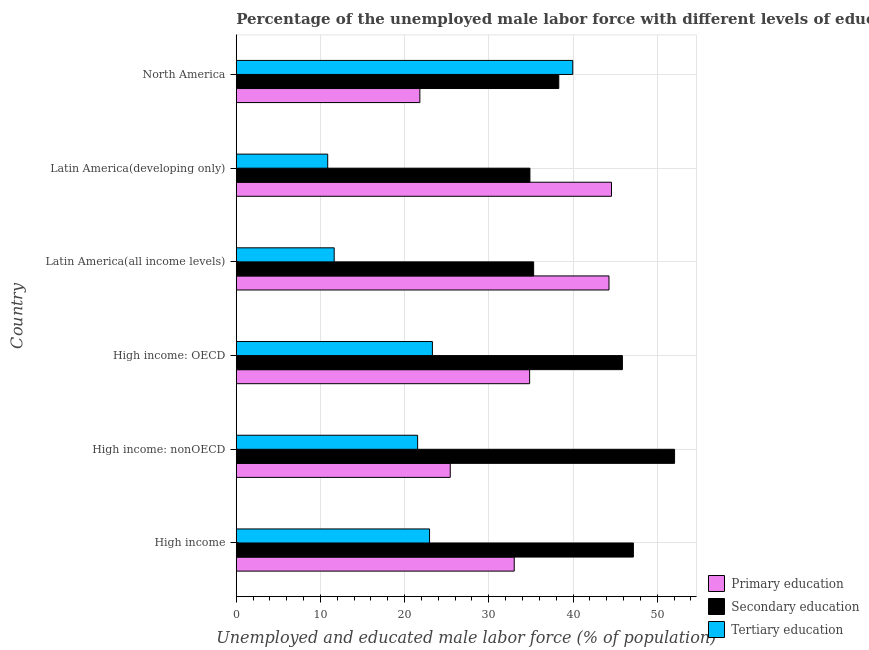Are the number of bars per tick equal to the number of legend labels?
Ensure brevity in your answer.  Yes. Are the number of bars on each tick of the Y-axis equal?
Provide a short and direct response. Yes. What is the label of the 3rd group of bars from the top?
Ensure brevity in your answer.  Latin America(all income levels). What is the percentage of male labor force who received tertiary education in High income: nonOECD?
Make the answer very short. 21.54. Across all countries, what is the maximum percentage of male labor force who received tertiary education?
Give a very brief answer. 39.97. Across all countries, what is the minimum percentage of male labor force who received tertiary education?
Your answer should be very brief. 10.86. In which country was the percentage of male labor force who received secondary education maximum?
Your response must be concise. High income: nonOECD. In which country was the percentage of male labor force who received primary education minimum?
Your response must be concise. North America. What is the total percentage of male labor force who received primary education in the graph?
Provide a short and direct response. 203.93. What is the difference between the percentage of male labor force who received primary education in High income and that in High income: nonOECD?
Your response must be concise. 7.6. What is the difference between the percentage of male labor force who received primary education in High income: OECD and the percentage of male labor force who received tertiary education in Latin America(all income levels)?
Give a very brief answer. 23.21. What is the average percentage of male labor force who received tertiary education per country?
Your response must be concise. 21.71. What is the difference between the percentage of male labor force who received tertiary education and percentage of male labor force who received secondary education in North America?
Make the answer very short. 1.66. What is the ratio of the percentage of male labor force who received secondary education in High income: nonOECD to that in Latin America(all income levels)?
Ensure brevity in your answer.  1.47. Is the percentage of male labor force who received primary education in High income: OECD less than that in North America?
Offer a very short reply. No. What is the difference between the highest and the second highest percentage of male labor force who received secondary education?
Your answer should be compact. 4.89. What is the difference between the highest and the lowest percentage of male labor force who received tertiary education?
Provide a succinct answer. 29.11. In how many countries, is the percentage of male labor force who received primary education greater than the average percentage of male labor force who received primary education taken over all countries?
Provide a short and direct response. 3. Is the sum of the percentage of male labor force who received primary education in High income: nonOECD and Latin America(all income levels) greater than the maximum percentage of male labor force who received tertiary education across all countries?
Ensure brevity in your answer.  Yes. What does the 2nd bar from the top in North America represents?
Your response must be concise. Secondary education. Does the graph contain any zero values?
Your answer should be compact. No. How many legend labels are there?
Provide a succinct answer. 3. How are the legend labels stacked?
Give a very brief answer. Vertical. What is the title of the graph?
Provide a short and direct response. Percentage of the unemployed male labor force with different levels of education in countries. Does "Domestic economy" appear as one of the legend labels in the graph?
Offer a terse response. No. What is the label or title of the X-axis?
Provide a succinct answer. Unemployed and educated male labor force (% of population). What is the label or title of the Y-axis?
Ensure brevity in your answer.  Country. What is the Unemployed and educated male labor force (% of population) of Primary education in High income?
Your answer should be compact. 33.02. What is the Unemployed and educated male labor force (% of population) of Secondary education in High income?
Make the answer very short. 47.17. What is the Unemployed and educated male labor force (% of population) in Tertiary education in High income?
Ensure brevity in your answer.  22.96. What is the Unemployed and educated male labor force (% of population) of Primary education in High income: nonOECD?
Keep it short and to the point. 25.42. What is the Unemployed and educated male labor force (% of population) in Secondary education in High income: nonOECD?
Ensure brevity in your answer.  52.06. What is the Unemployed and educated male labor force (% of population) in Tertiary education in High income: nonOECD?
Offer a terse response. 21.54. What is the Unemployed and educated male labor force (% of population) of Primary education in High income: OECD?
Offer a very short reply. 34.84. What is the Unemployed and educated male labor force (% of population) in Secondary education in High income: OECD?
Your answer should be compact. 45.86. What is the Unemployed and educated male labor force (% of population) in Tertiary education in High income: OECD?
Give a very brief answer. 23.3. What is the Unemployed and educated male labor force (% of population) of Primary education in Latin America(all income levels)?
Your answer should be very brief. 44.27. What is the Unemployed and educated male labor force (% of population) of Secondary education in Latin America(all income levels)?
Ensure brevity in your answer.  35.32. What is the Unemployed and educated male labor force (% of population) of Tertiary education in Latin America(all income levels)?
Your answer should be very brief. 11.63. What is the Unemployed and educated male labor force (% of population) in Primary education in Latin America(developing only)?
Your answer should be compact. 44.57. What is the Unemployed and educated male labor force (% of population) of Secondary education in Latin America(developing only)?
Offer a very short reply. 34.88. What is the Unemployed and educated male labor force (% of population) in Tertiary education in Latin America(developing only)?
Make the answer very short. 10.86. What is the Unemployed and educated male labor force (% of population) of Primary education in North America?
Your response must be concise. 21.81. What is the Unemployed and educated male labor force (% of population) in Secondary education in North America?
Make the answer very short. 38.31. What is the Unemployed and educated male labor force (% of population) in Tertiary education in North America?
Keep it short and to the point. 39.97. Across all countries, what is the maximum Unemployed and educated male labor force (% of population) of Primary education?
Provide a succinct answer. 44.57. Across all countries, what is the maximum Unemployed and educated male labor force (% of population) of Secondary education?
Offer a terse response. 52.06. Across all countries, what is the maximum Unemployed and educated male labor force (% of population) in Tertiary education?
Your answer should be very brief. 39.97. Across all countries, what is the minimum Unemployed and educated male labor force (% of population) in Primary education?
Your response must be concise. 21.81. Across all countries, what is the minimum Unemployed and educated male labor force (% of population) in Secondary education?
Keep it short and to the point. 34.88. Across all countries, what is the minimum Unemployed and educated male labor force (% of population) in Tertiary education?
Provide a short and direct response. 10.86. What is the total Unemployed and educated male labor force (% of population) in Primary education in the graph?
Your answer should be very brief. 203.93. What is the total Unemployed and educated male labor force (% of population) in Secondary education in the graph?
Your response must be concise. 253.61. What is the total Unemployed and educated male labor force (% of population) in Tertiary education in the graph?
Give a very brief answer. 130.27. What is the difference between the Unemployed and educated male labor force (% of population) of Primary education in High income and that in High income: nonOECD?
Keep it short and to the point. 7.6. What is the difference between the Unemployed and educated male labor force (% of population) in Secondary education in High income and that in High income: nonOECD?
Offer a very short reply. -4.89. What is the difference between the Unemployed and educated male labor force (% of population) in Tertiary education in High income and that in High income: nonOECD?
Offer a terse response. 1.42. What is the difference between the Unemployed and educated male labor force (% of population) of Primary education in High income and that in High income: OECD?
Your response must be concise. -1.83. What is the difference between the Unemployed and educated male labor force (% of population) of Secondary education in High income and that in High income: OECD?
Provide a succinct answer. 1.31. What is the difference between the Unemployed and educated male labor force (% of population) in Tertiary education in High income and that in High income: OECD?
Offer a terse response. -0.34. What is the difference between the Unemployed and educated male labor force (% of population) of Primary education in High income and that in Latin America(all income levels)?
Offer a very short reply. -11.26. What is the difference between the Unemployed and educated male labor force (% of population) of Secondary education in High income and that in Latin America(all income levels)?
Your answer should be compact. 11.85. What is the difference between the Unemployed and educated male labor force (% of population) in Tertiary education in High income and that in Latin America(all income levels)?
Make the answer very short. 11.33. What is the difference between the Unemployed and educated male labor force (% of population) in Primary education in High income and that in Latin America(developing only)?
Provide a short and direct response. -11.55. What is the difference between the Unemployed and educated male labor force (% of population) in Secondary education in High income and that in Latin America(developing only)?
Your answer should be very brief. 12.29. What is the difference between the Unemployed and educated male labor force (% of population) of Tertiary education in High income and that in Latin America(developing only)?
Give a very brief answer. 12.1. What is the difference between the Unemployed and educated male labor force (% of population) of Primary education in High income and that in North America?
Provide a succinct answer. 11.21. What is the difference between the Unemployed and educated male labor force (% of population) in Secondary education in High income and that in North America?
Offer a terse response. 8.86. What is the difference between the Unemployed and educated male labor force (% of population) in Tertiary education in High income and that in North America?
Provide a short and direct response. -17.01. What is the difference between the Unemployed and educated male labor force (% of population) in Primary education in High income: nonOECD and that in High income: OECD?
Your response must be concise. -9.43. What is the difference between the Unemployed and educated male labor force (% of population) of Secondary education in High income: nonOECD and that in High income: OECD?
Make the answer very short. 6.2. What is the difference between the Unemployed and educated male labor force (% of population) in Tertiary education in High income: nonOECD and that in High income: OECD?
Ensure brevity in your answer.  -1.76. What is the difference between the Unemployed and educated male labor force (% of population) in Primary education in High income: nonOECD and that in Latin America(all income levels)?
Offer a terse response. -18.85. What is the difference between the Unemployed and educated male labor force (% of population) of Secondary education in High income: nonOECD and that in Latin America(all income levels)?
Your answer should be compact. 16.74. What is the difference between the Unemployed and educated male labor force (% of population) of Tertiary education in High income: nonOECD and that in Latin America(all income levels)?
Offer a terse response. 9.91. What is the difference between the Unemployed and educated male labor force (% of population) in Primary education in High income: nonOECD and that in Latin America(developing only)?
Your response must be concise. -19.15. What is the difference between the Unemployed and educated male labor force (% of population) of Secondary education in High income: nonOECD and that in Latin America(developing only)?
Provide a succinct answer. 17.18. What is the difference between the Unemployed and educated male labor force (% of population) of Tertiary education in High income: nonOECD and that in Latin America(developing only)?
Give a very brief answer. 10.68. What is the difference between the Unemployed and educated male labor force (% of population) in Primary education in High income: nonOECD and that in North America?
Your response must be concise. 3.61. What is the difference between the Unemployed and educated male labor force (% of population) in Secondary education in High income: nonOECD and that in North America?
Your response must be concise. 13.75. What is the difference between the Unemployed and educated male labor force (% of population) of Tertiary education in High income: nonOECD and that in North America?
Your answer should be very brief. -18.43. What is the difference between the Unemployed and educated male labor force (% of population) of Primary education in High income: OECD and that in Latin America(all income levels)?
Keep it short and to the point. -9.43. What is the difference between the Unemployed and educated male labor force (% of population) in Secondary education in High income: OECD and that in Latin America(all income levels)?
Keep it short and to the point. 10.54. What is the difference between the Unemployed and educated male labor force (% of population) in Tertiary education in High income: OECD and that in Latin America(all income levels)?
Offer a terse response. 11.67. What is the difference between the Unemployed and educated male labor force (% of population) of Primary education in High income: OECD and that in Latin America(developing only)?
Offer a very short reply. -9.72. What is the difference between the Unemployed and educated male labor force (% of population) in Secondary education in High income: OECD and that in Latin America(developing only)?
Ensure brevity in your answer.  10.98. What is the difference between the Unemployed and educated male labor force (% of population) of Tertiary education in High income: OECD and that in Latin America(developing only)?
Provide a succinct answer. 12.44. What is the difference between the Unemployed and educated male labor force (% of population) of Primary education in High income: OECD and that in North America?
Provide a succinct answer. 13.04. What is the difference between the Unemployed and educated male labor force (% of population) in Secondary education in High income: OECD and that in North America?
Keep it short and to the point. 7.55. What is the difference between the Unemployed and educated male labor force (% of population) in Tertiary education in High income: OECD and that in North America?
Make the answer very short. -16.67. What is the difference between the Unemployed and educated male labor force (% of population) in Primary education in Latin America(all income levels) and that in Latin America(developing only)?
Your response must be concise. -0.3. What is the difference between the Unemployed and educated male labor force (% of population) of Secondary education in Latin America(all income levels) and that in Latin America(developing only)?
Your response must be concise. 0.44. What is the difference between the Unemployed and educated male labor force (% of population) in Tertiary education in Latin America(all income levels) and that in Latin America(developing only)?
Make the answer very short. 0.77. What is the difference between the Unemployed and educated male labor force (% of population) of Primary education in Latin America(all income levels) and that in North America?
Offer a terse response. 22.46. What is the difference between the Unemployed and educated male labor force (% of population) of Secondary education in Latin America(all income levels) and that in North America?
Your response must be concise. -2.99. What is the difference between the Unemployed and educated male labor force (% of population) in Tertiary education in Latin America(all income levels) and that in North America?
Give a very brief answer. -28.34. What is the difference between the Unemployed and educated male labor force (% of population) in Primary education in Latin America(developing only) and that in North America?
Ensure brevity in your answer.  22.76. What is the difference between the Unemployed and educated male labor force (% of population) in Secondary education in Latin America(developing only) and that in North America?
Your answer should be compact. -3.43. What is the difference between the Unemployed and educated male labor force (% of population) in Tertiary education in Latin America(developing only) and that in North America?
Provide a short and direct response. -29.11. What is the difference between the Unemployed and educated male labor force (% of population) of Primary education in High income and the Unemployed and educated male labor force (% of population) of Secondary education in High income: nonOECD?
Your answer should be compact. -19.04. What is the difference between the Unemployed and educated male labor force (% of population) of Primary education in High income and the Unemployed and educated male labor force (% of population) of Tertiary education in High income: nonOECD?
Your answer should be compact. 11.47. What is the difference between the Unemployed and educated male labor force (% of population) in Secondary education in High income and the Unemployed and educated male labor force (% of population) in Tertiary education in High income: nonOECD?
Ensure brevity in your answer.  25.63. What is the difference between the Unemployed and educated male labor force (% of population) in Primary education in High income and the Unemployed and educated male labor force (% of population) in Secondary education in High income: OECD?
Provide a succinct answer. -12.85. What is the difference between the Unemployed and educated male labor force (% of population) in Primary education in High income and the Unemployed and educated male labor force (% of population) in Tertiary education in High income: OECD?
Ensure brevity in your answer.  9.72. What is the difference between the Unemployed and educated male labor force (% of population) in Secondary education in High income and the Unemployed and educated male labor force (% of population) in Tertiary education in High income: OECD?
Keep it short and to the point. 23.87. What is the difference between the Unemployed and educated male labor force (% of population) in Primary education in High income and the Unemployed and educated male labor force (% of population) in Secondary education in Latin America(all income levels)?
Provide a succinct answer. -2.31. What is the difference between the Unemployed and educated male labor force (% of population) of Primary education in High income and the Unemployed and educated male labor force (% of population) of Tertiary education in Latin America(all income levels)?
Keep it short and to the point. 21.38. What is the difference between the Unemployed and educated male labor force (% of population) of Secondary education in High income and the Unemployed and educated male labor force (% of population) of Tertiary education in Latin America(all income levels)?
Make the answer very short. 35.54. What is the difference between the Unemployed and educated male labor force (% of population) in Primary education in High income and the Unemployed and educated male labor force (% of population) in Secondary education in Latin America(developing only)?
Offer a terse response. -1.86. What is the difference between the Unemployed and educated male labor force (% of population) of Primary education in High income and the Unemployed and educated male labor force (% of population) of Tertiary education in Latin America(developing only)?
Your response must be concise. 22.15. What is the difference between the Unemployed and educated male labor force (% of population) of Secondary education in High income and the Unemployed and educated male labor force (% of population) of Tertiary education in Latin America(developing only)?
Your response must be concise. 36.31. What is the difference between the Unemployed and educated male labor force (% of population) in Primary education in High income and the Unemployed and educated male labor force (% of population) in Secondary education in North America?
Keep it short and to the point. -5.29. What is the difference between the Unemployed and educated male labor force (% of population) of Primary education in High income and the Unemployed and educated male labor force (% of population) of Tertiary education in North America?
Offer a terse response. -6.95. What is the difference between the Unemployed and educated male labor force (% of population) of Secondary education in High income and the Unemployed and educated male labor force (% of population) of Tertiary education in North America?
Your answer should be compact. 7.2. What is the difference between the Unemployed and educated male labor force (% of population) of Primary education in High income: nonOECD and the Unemployed and educated male labor force (% of population) of Secondary education in High income: OECD?
Make the answer very short. -20.45. What is the difference between the Unemployed and educated male labor force (% of population) of Primary education in High income: nonOECD and the Unemployed and educated male labor force (% of population) of Tertiary education in High income: OECD?
Keep it short and to the point. 2.12. What is the difference between the Unemployed and educated male labor force (% of population) in Secondary education in High income: nonOECD and the Unemployed and educated male labor force (% of population) in Tertiary education in High income: OECD?
Provide a short and direct response. 28.76. What is the difference between the Unemployed and educated male labor force (% of population) in Primary education in High income: nonOECD and the Unemployed and educated male labor force (% of population) in Secondary education in Latin America(all income levels)?
Give a very brief answer. -9.9. What is the difference between the Unemployed and educated male labor force (% of population) in Primary education in High income: nonOECD and the Unemployed and educated male labor force (% of population) in Tertiary education in Latin America(all income levels)?
Give a very brief answer. 13.79. What is the difference between the Unemployed and educated male labor force (% of population) of Secondary education in High income: nonOECD and the Unemployed and educated male labor force (% of population) of Tertiary education in Latin America(all income levels)?
Offer a terse response. 40.43. What is the difference between the Unemployed and educated male labor force (% of population) in Primary education in High income: nonOECD and the Unemployed and educated male labor force (% of population) in Secondary education in Latin America(developing only)?
Your answer should be very brief. -9.46. What is the difference between the Unemployed and educated male labor force (% of population) in Primary education in High income: nonOECD and the Unemployed and educated male labor force (% of population) in Tertiary education in Latin America(developing only)?
Provide a succinct answer. 14.56. What is the difference between the Unemployed and educated male labor force (% of population) in Secondary education in High income: nonOECD and the Unemployed and educated male labor force (% of population) in Tertiary education in Latin America(developing only)?
Give a very brief answer. 41.2. What is the difference between the Unemployed and educated male labor force (% of population) of Primary education in High income: nonOECD and the Unemployed and educated male labor force (% of population) of Secondary education in North America?
Offer a very short reply. -12.89. What is the difference between the Unemployed and educated male labor force (% of population) in Primary education in High income: nonOECD and the Unemployed and educated male labor force (% of population) in Tertiary education in North America?
Your answer should be compact. -14.55. What is the difference between the Unemployed and educated male labor force (% of population) of Secondary education in High income: nonOECD and the Unemployed and educated male labor force (% of population) of Tertiary education in North America?
Give a very brief answer. 12.09. What is the difference between the Unemployed and educated male labor force (% of population) in Primary education in High income: OECD and the Unemployed and educated male labor force (% of population) in Secondary education in Latin America(all income levels)?
Provide a succinct answer. -0.48. What is the difference between the Unemployed and educated male labor force (% of population) of Primary education in High income: OECD and the Unemployed and educated male labor force (% of population) of Tertiary education in Latin America(all income levels)?
Offer a terse response. 23.21. What is the difference between the Unemployed and educated male labor force (% of population) in Secondary education in High income: OECD and the Unemployed and educated male labor force (% of population) in Tertiary education in Latin America(all income levels)?
Your response must be concise. 34.23. What is the difference between the Unemployed and educated male labor force (% of population) of Primary education in High income: OECD and the Unemployed and educated male labor force (% of population) of Secondary education in Latin America(developing only)?
Ensure brevity in your answer.  -0.04. What is the difference between the Unemployed and educated male labor force (% of population) in Primary education in High income: OECD and the Unemployed and educated male labor force (% of population) in Tertiary education in Latin America(developing only)?
Make the answer very short. 23.98. What is the difference between the Unemployed and educated male labor force (% of population) of Secondary education in High income: OECD and the Unemployed and educated male labor force (% of population) of Tertiary education in Latin America(developing only)?
Provide a short and direct response. 35. What is the difference between the Unemployed and educated male labor force (% of population) in Primary education in High income: OECD and the Unemployed and educated male labor force (% of population) in Secondary education in North America?
Ensure brevity in your answer.  -3.46. What is the difference between the Unemployed and educated male labor force (% of population) of Primary education in High income: OECD and the Unemployed and educated male labor force (% of population) of Tertiary education in North America?
Offer a very short reply. -5.12. What is the difference between the Unemployed and educated male labor force (% of population) in Secondary education in High income: OECD and the Unemployed and educated male labor force (% of population) in Tertiary education in North America?
Provide a short and direct response. 5.89. What is the difference between the Unemployed and educated male labor force (% of population) of Primary education in Latin America(all income levels) and the Unemployed and educated male labor force (% of population) of Secondary education in Latin America(developing only)?
Offer a very short reply. 9.39. What is the difference between the Unemployed and educated male labor force (% of population) of Primary education in Latin America(all income levels) and the Unemployed and educated male labor force (% of population) of Tertiary education in Latin America(developing only)?
Provide a short and direct response. 33.41. What is the difference between the Unemployed and educated male labor force (% of population) in Secondary education in Latin America(all income levels) and the Unemployed and educated male labor force (% of population) in Tertiary education in Latin America(developing only)?
Provide a short and direct response. 24.46. What is the difference between the Unemployed and educated male labor force (% of population) in Primary education in Latin America(all income levels) and the Unemployed and educated male labor force (% of population) in Secondary education in North America?
Provide a succinct answer. 5.96. What is the difference between the Unemployed and educated male labor force (% of population) in Primary education in Latin America(all income levels) and the Unemployed and educated male labor force (% of population) in Tertiary education in North America?
Your response must be concise. 4.3. What is the difference between the Unemployed and educated male labor force (% of population) of Secondary education in Latin America(all income levels) and the Unemployed and educated male labor force (% of population) of Tertiary education in North America?
Your response must be concise. -4.65. What is the difference between the Unemployed and educated male labor force (% of population) in Primary education in Latin America(developing only) and the Unemployed and educated male labor force (% of population) in Secondary education in North America?
Give a very brief answer. 6.26. What is the difference between the Unemployed and educated male labor force (% of population) of Primary education in Latin America(developing only) and the Unemployed and educated male labor force (% of population) of Tertiary education in North America?
Offer a very short reply. 4.6. What is the difference between the Unemployed and educated male labor force (% of population) of Secondary education in Latin America(developing only) and the Unemployed and educated male labor force (% of population) of Tertiary education in North America?
Provide a succinct answer. -5.09. What is the average Unemployed and educated male labor force (% of population) in Primary education per country?
Offer a very short reply. 33.99. What is the average Unemployed and educated male labor force (% of population) of Secondary education per country?
Ensure brevity in your answer.  42.27. What is the average Unemployed and educated male labor force (% of population) in Tertiary education per country?
Ensure brevity in your answer.  21.71. What is the difference between the Unemployed and educated male labor force (% of population) of Primary education and Unemployed and educated male labor force (% of population) of Secondary education in High income?
Provide a short and direct response. -14.15. What is the difference between the Unemployed and educated male labor force (% of population) of Primary education and Unemployed and educated male labor force (% of population) of Tertiary education in High income?
Your answer should be compact. 10.06. What is the difference between the Unemployed and educated male labor force (% of population) of Secondary education and Unemployed and educated male labor force (% of population) of Tertiary education in High income?
Give a very brief answer. 24.21. What is the difference between the Unemployed and educated male labor force (% of population) in Primary education and Unemployed and educated male labor force (% of population) in Secondary education in High income: nonOECD?
Ensure brevity in your answer.  -26.64. What is the difference between the Unemployed and educated male labor force (% of population) in Primary education and Unemployed and educated male labor force (% of population) in Tertiary education in High income: nonOECD?
Make the answer very short. 3.87. What is the difference between the Unemployed and educated male labor force (% of population) of Secondary education and Unemployed and educated male labor force (% of population) of Tertiary education in High income: nonOECD?
Keep it short and to the point. 30.52. What is the difference between the Unemployed and educated male labor force (% of population) of Primary education and Unemployed and educated male labor force (% of population) of Secondary education in High income: OECD?
Offer a terse response. -11.02. What is the difference between the Unemployed and educated male labor force (% of population) of Primary education and Unemployed and educated male labor force (% of population) of Tertiary education in High income: OECD?
Ensure brevity in your answer.  11.55. What is the difference between the Unemployed and educated male labor force (% of population) in Secondary education and Unemployed and educated male labor force (% of population) in Tertiary education in High income: OECD?
Ensure brevity in your answer.  22.56. What is the difference between the Unemployed and educated male labor force (% of population) of Primary education and Unemployed and educated male labor force (% of population) of Secondary education in Latin America(all income levels)?
Your answer should be very brief. 8.95. What is the difference between the Unemployed and educated male labor force (% of population) of Primary education and Unemployed and educated male labor force (% of population) of Tertiary education in Latin America(all income levels)?
Offer a terse response. 32.64. What is the difference between the Unemployed and educated male labor force (% of population) in Secondary education and Unemployed and educated male labor force (% of population) in Tertiary education in Latin America(all income levels)?
Your answer should be very brief. 23.69. What is the difference between the Unemployed and educated male labor force (% of population) of Primary education and Unemployed and educated male labor force (% of population) of Secondary education in Latin America(developing only)?
Offer a terse response. 9.69. What is the difference between the Unemployed and educated male labor force (% of population) of Primary education and Unemployed and educated male labor force (% of population) of Tertiary education in Latin America(developing only)?
Your answer should be very brief. 33.71. What is the difference between the Unemployed and educated male labor force (% of population) in Secondary education and Unemployed and educated male labor force (% of population) in Tertiary education in Latin America(developing only)?
Keep it short and to the point. 24.02. What is the difference between the Unemployed and educated male labor force (% of population) of Primary education and Unemployed and educated male labor force (% of population) of Secondary education in North America?
Ensure brevity in your answer.  -16.5. What is the difference between the Unemployed and educated male labor force (% of population) of Primary education and Unemployed and educated male labor force (% of population) of Tertiary education in North America?
Your answer should be compact. -18.16. What is the difference between the Unemployed and educated male labor force (% of population) in Secondary education and Unemployed and educated male labor force (% of population) in Tertiary education in North America?
Provide a short and direct response. -1.66. What is the ratio of the Unemployed and educated male labor force (% of population) of Primary education in High income to that in High income: nonOECD?
Offer a very short reply. 1.3. What is the ratio of the Unemployed and educated male labor force (% of population) in Secondary education in High income to that in High income: nonOECD?
Your answer should be compact. 0.91. What is the ratio of the Unemployed and educated male labor force (% of population) of Tertiary education in High income to that in High income: nonOECD?
Provide a succinct answer. 1.07. What is the ratio of the Unemployed and educated male labor force (% of population) of Primary education in High income to that in High income: OECD?
Your answer should be very brief. 0.95. What is the ratio of the Unemployed and educated male labor force (% of population) in Secondary education in High income to that in High income: OECD?
Your answer should be very brief. 1.03. What is the ratio of the Unemployed and educated male labor force (% of population) of Tertiary education in High income to that in High income: OECD?
Your answer should be compact. 0.99. What is the ratio of the Unemployed and educated male labor force (% of population) in Primary education in High income to that in Latin America(all income levels)?
Offer a very short reply. 0.75. What is the ratio of the Unemployed and educated male labor force (% of population) in Secondary education in High income to that in Latin America(all income levels)?
Your answer should be compact. 1.34. What is the ratio of the Unemployed and educated male labor force (% of population) of Tertiary education in High income to that in Latin America(all income levels)?
Make the answer very short. 1.97. What is the ratio of the Unemployed and educated male labor force (% of population) of Primary education in High income to that in Latin America(developing only)?
Ensure brevity in your answer.  0.74. What is the ratio of the Unemployed and educated male labor force (% of population) of Secondary education in High income to that in Latin America(developing only)?
Ensure brevity in your answer.  1.35. What is the ratio of the Unemployed and educated male labor force (% of population) in Tertiary education in High income to that in Latin America(developing only)?
Offer a very short reply. 2.11. What is the ratio of the Unemployed and educated male labor force (% of population) of Primary education in High income to that in North America?
Ensure brevity in your answer.  1.51. What is the ratio of the Unemployed and educated male labor force (% of population) in Secondary education in High income to that in North America?
Offer a very short reply. 1.23. What is the ratio of the Unemployed and educated male labor force (% of population) of Tertiary education in High income to that in North America?
Provide a short and direct response. 0.57. What is the ratio of the Unemployed and educated male labor force (% of population) in Primary education in High income: nonOECD to that in High income: OECD?
Provide a succinct answer. 0.73. What is the ratio of the Unemployed and educated male labor force (% of population) in Secondary education in High income: nonOECD to that in High income: OECD?
Provide a succinct answer. 1.14. What is the ratio of the Unemployed and educated male labor force (% of population) of Tertiary education in High income: nonOECD to that in High income: OECD?
Your response must be concise. 0.92. What is the ratio of the Unemployed and educated male labor force (% of population) of Primary education in High income: nonOECD to that in Latin America(all income levels)?
Offer a very short reply. 0.57. What is the ratio of the Unemployed and educated male labor force (% of population) in Secondary education in High income: nonOECD to that in Latin America(all income levels)?
Ensure brevity in your answer.  1.47. What is the ratio of the Unemployed and educated male labor force (% of population) of Tertiary education in High income: nonOECD to that in Latin America(all income levels)?
Make the answer very short. 1.85. What is the ratio of the Unemployed and educated male labor force (% of population) of Primary education in High income: nonOECD to that in Latin America(developing only)?
Provide a succinct answer. 0.57. What is the ratio of the Unemployed and educated male labor force (% of population) of Secondary education in High income: nonOECD to that in Latin America(developing only)?
Your answer should be very brief. 1.49. What is the ratio of the Unemployed and educated male labor force (% of population) of Tertiary education in High income: nonOECD to that in Latin America(developing only)?
Provide a short and direct response. 1.98. What is the ratio of the Unemployed and educated male labor force (% of population) of Primary education in High income: nonOECD to that in North America?
Give a very brief answer. 1.17. What is the ratio of the Unemployed and educated male labor force (% of population) of Secondary education in High income: nonOECD to that in North America?
Your answer should be very brief. 1.36. What is the ratio of the Unemployed and educated male labor force (% of population) of Tertiary education in High income: nonOECD to that in North America?
Make the answer very short. 0.54. What is the ratio of the Unemployed and educated male labor force (% of population) in Primary education in High income: OECD to that in Latin America(all income levels)?
Make the answer very short. 0.79. What is the ratio of the Unemployed and educated male labor force (% of population) of Secondary education in High income: OECD to that in Latin America(all income levels)?
Ensure brevity in your answer.  1.3. What is the ratio of the Unemployed and educated male labor force (% of population) in Tertiary education in High income: OECD to that in Latin America(all income levels)?
Give a very brief answer. 2. What is the ratio of the Unemployed and educated male labor force (% of population) in Primary education in High income: OECD to that in Latin America(developing only)?
Ensure brevity in your answer.  0.78. What is the ratio of the Unemployed and educated male labor force (% of population) of Secondary education in High income: OECD to that in Latin America(developing only)?
Your response must be concise. 1.31. What is the ratio of the Unemployed and educated male labor force (% of population) in Tertiary education in High income: OECD to that in Latin America(developing only)?
Offer a terse response. 2.14. What is the ratio of the Unemployed and educated male labor force (% of population) in Primary education in High income: OECD to that in North America?
Offer a terse response. 1.6. What is the ratio of the Unemployed and educated male labor force (% of population) in Secondary education in High income: OECD to that in North America?
Ensure brevity in your answer.  1.2. What is the ratio of the Unemployed and educated male labor force (% of population) in Tertiary education in High income: OECD to that in North America?
Provide a short and direct response. 0.58. What is the ratio of the Unemployed and educated male labor force (% of population) in Secondary education in Latin America(all income levels) to that in Latin America(developing only)?
Give a very brief answer. 1.01. What is the ratio of the Unemployed and educated male labor force (% of population) in Tertiary education in Latin America(all income levels) to that in Latin America(developing only)?
Provide a succinct answer. 1.07. What is the ratio of the Unemployed and educated male labor force (% of population) of Primary education in Latin America(all income levels) to that in North America?
Ensure brevity in your answer.  2.03. What is the ratio of the Unemployed and educated male labor force (% of population) of Secondary education in Latin America(all income levels) to that in North America?
Your answer should be very brief. 0.92. What is the ratio of the Unemployed and educated male labor force (% of population) in Tertiary education in Latin America(all income levels) to that in North America?
Make the answer very short. 0.29. What is the ratio of the Unemployed and educated male labor force (% of population) of Primary education in Latin America(developing only) to that in North America?
Provide a succinct answer. 2.04. What is the ratio of the Unemployed and educated male labor force (% of population) of Secondary education in Latin America(developing only) to that in North America?
Give a very brief answer. 0.91. What is the ratio of the Unemployed and educated male labor force (% of population) of Tertiary education in Latin America(developing only) to that in North America?
Offer a very short reply. 0.27. What is the difference between the highest and the second highest Unemployed and educated male labor force (% of population) in Primary education?
Provide a succinct answer. 0.3. What is the difference between the highest and the second highest Unemployed and educated male labor force (% of population) of Secondary education?
Ensure brevity in your answer.  4.89. What is the difference between the highest and the second highest Unemployed and educated male labor force (% of population) in Tertiary education?
Make the answer very short. 16.67. What is the difference between the highest and the lowest Unemployed and educated male labor force (% of population) of Primary education?
Provide a succinct answer. 22.76. What is the difference between the highest and the lowest Unemployed and educated male labor force (% of population) of Secondary education?
Ensure brevity in your answer.  17.18. What is the difference between the highest and the lowest Unemployed and educated male labor force (% of population) in Tertiary education?
Make the answer very short. 29.11. 